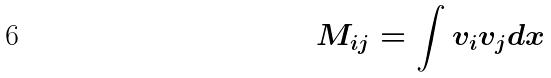<formula> <loc_0><loc_0><loc_500><loc_500>M _ { i j } = \int v _ { i } v _ { j } d x</formula> 